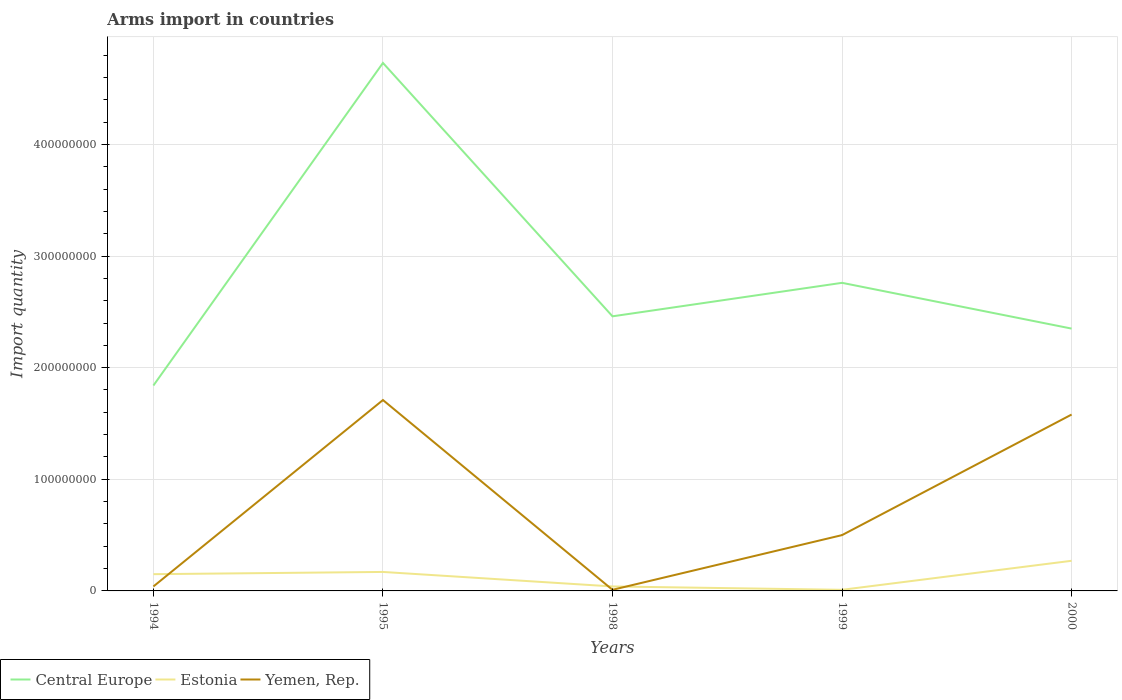In which year was the total arms import in Yemen, Rep. maximum?
Make the answer very short. 1998. What is the total total arms import in Central Europe in the graph?
Offer a very short reply. -9.20e+07. What is the difference between the highest and the second highest total arms import in Estonia?
Provide a succinct answer. 2.60e+07. What is the difference between the highest and the lowest total arms import in Central Europe?
Make the answer very short. 1. How many lines are there?
Give a very brief answer. 3. How many years are there in the graph?
Offer a very short reply. 5. Are the values on the major ticks of Y-axis written in scientific E-notation?
Offer a terse response. No. Does the graph contain grids?
Your response must be concise. Yes. Where does the legend appear in the graph?
Your answer should be compact. Bottom left. How are the legend labels stacked?
Offer a very short reply. Horizontal. What is the title of the graph?
Ensure brevity in your answer.  Arms import in countries. Does "Bhutan" appear as one of the legend labels in the graph?
Ensure brevity in your answer.  No. What is the label or title of the Y-axis?
Offer a terse response. Import quantity. What is the Import quantity of Central Europe in 1994?
Your answer should be compact. 1.84e+08. What is the Import quantity in Estonia in 1994?
Your response must be concise. 1.50e+07. What is the Import quantity of Yemen, Rep. in 1994?
Your answer should be compact. 4.00e+06. What is the Import quantity of Central Europe in 1995?
Make the answer very short. 4.73e+08. What is the Import quantity of Estonia in 1995?
Your answer should be compact. 1.70e+07. What is the Import quantity in Yemen, Rep. in 1995?
Provide a short and direct response. 1.71e+08. What is the Import quantity of Central Europe in 1998?
Give a very brief answer. 2.46e+08. What is the Import quantity in Central Europe in 1999?
Give a very brief answer. 2.76e+08. What is the Import quantity in Estonia in 1999?
Ensure brevity in your answer.  1.00e+06. What is the Import quantity of Yemen, Rep. in 1999?
Offer a terse response. 5.00e+07. What is the Import quantity of Central Europe in 2000?
Offer a terse response. 2.35e+08. What is the Import quantity of Estonia in 2000?
Your answer should be very brief. 2.70e+07. What is the Import quantity of Yemen, Rep. in 2000?
Give a very brief answer. 1.58e+08. Across all years, what is the maximum Import quantity of Central Europe?
Ensure brevity in your answer.  4.73e+08. Across all years, what is the maximum Import quantity of Estonia?
Ensure brevity in your answer.  2.70e+07. Across all years, what is the maximum Import quantity of Yemen, Rep.?
Provide a succinct answer. 1.71e+08. Across all years, what is the minimum Import quantity in Central Europe?
Offer a terse response. 1.84e+08. Across all years, what is the minimum Import quantity in Yemen, Rep.?
Your answer should be very brief. 1.00e+06. What is the total Import quantity in Central Europe in the graph?
Your answer should be very brief. 1.41e+09. What is the total Import quantity of Estonia in the graph?
Give a very brief answer. 6.40e+07. What is the total Import quantity in Yemen, Rep. in the graph?
Offer a terse response. 3.84e+08. What is the difference between the Import quantity of Central Europe in 1994 and that in 1995?
Offer a very short reply. -2.89e+08. What is the difference between the Import quantity in Estonia in 1994 and that in 1995?
Ensure brevity in your answer.  -2.00e+06. What is the difference between the Import quantity in Yemen, Rep. in 1994 and that in 1995?
Provide a short and direct response. -1.67e+08. What is the difference between the Import quantity of Central Europe in 1994 and that in 1998?
Offer a very short reply. -6.20e+07. What is the difference between the Import quantity of Estonia in 1994 and that in 1998?
Ensure brevity in your answer.  1.10e+07. What is the difference between the Import quantity of Yemen, Rep. in 1994 and that in 1998?
Make the answer very short. 3.00e+06. What is the difference between the Import quantity of Central Europe in 1994 and that in 1999?
Provide a short and direct response. -9.20e+07. What is the difference between the Import quantity in Estonia in 1994 and that in 1999?
Provide a short and direct response. 1.40e+07. What is the difference between the Import quantity of Yemen, Rep. in 1994 and that in 1999?
Offer a terse response. -4.60e+07. What is the difference between the Import quantity in Central Europe in 1994 and that in 2000?
Give a very brief answer. -5.10e+07. What is the difference between the Import quantity in Estonia in 1994 and that in 2000?
Provide a short and direct response. -1.20e+07. What is the difference between the Import quantity of Yemen, Rep. in 1994 and that in 2000?
Provide a short and direct response. -1.54e+08. What is the difference between the Import quantity of Central Europe in 1995 and that in 1998?
Make the answer very short. 2.27e+08. What is the difference between the Import quantity in Estonia in 1995 and that in 1998?
Provide a succinct answer. 1.30e+07. What is the difference between the Import quantity in Yemen, Rep. in 1995 and that in 1998?
Offer a terse response. 1.70e+08. What is the difference between the Import quantity in Central Europe in 1995 and that in 1999?
Provide a short and direct response. 1.97e+08. What is the difference between the Import quantity of Estonia in 1995 and that in 1999?
Your response must be concise. 1.60e+07. What is the difference between the Import quantity in Yemen, Rep. in 1995 and that in 1999?
Make the answer very short. 1.21e+08. What is the difference between the Import quantity of Central Europe in 1995 and that in 2000?
Make the answer very short. 2.38e+08. What is the difference between the Import quantity of Estonia in 1995 and that in 2000?
Your response must be concise. -1.00e+07. What is the difference between the Import quantity in Yemen, Rep. in 1995 and that in 2000?
Give a very brief answer. 1.30e+07. What is the difference between the Import quantity in Central Europe in 1998 and that in 1999?
Your answer should be compact. -3.00e+07. What is the difference between the Import quantity in Estonia in 1998 and that in 1999?
Give a very brief answer. 3.00e+06. What is the difference between the Import quantity of Yemen, Rep. in 1998 and that in 1999?
Offer a very short reply. -4.90e+07. What is the difference between the Import quantity of Central Europe in 1998 and that in 2000?
Make the answer very short. 1.10e+07. What is the difference between the Import quantity of Estonia in 1998 and that in 2000?
Provide a short and direct response. -2.30e+07. What is the difference between the Import quantity in Yemen, Rep. in 1998 and that in 2000?
Make the answer very short. -1.57e+08. What is the difference between the Import quantity in Central Europe in 1999 and that in 2000?
Your answer should be very brief. 4.10e+07. What is the difference between the Import quantity in Estonia in 1999 and that in 2000?
Your answer should be very brief. -2.60e+07. What is the difference between the Import quantity of Yemen, Rep. in 1999 and that in 2000?
Make the answer very short. -1.08e+08. What is the difference between the Import quantity of Central Europe in 1994 and the Import quantity of Estonia in 1995?
Provide a short and direct response. 1.67e+08. What is the difference between the Import quantity of Central Europe in 1994 and the Import quantity of Yemen, Rep. in 1995?
Your answer should be compact. 1.30e+07. What is the difference between the Import quantity of Estonia in 1994 and the Import quantity of Yemen, Rep. in 1995?
Your response must be concise. -1.56e+08. What is the difference between the Import quantity of Central Europe in 1994 and the Import quantity of Estonia in 1998?
Provide a succinct answer. 1.80e+08. What is the difference between the Import quantity in Central Europe in 1994 and the Import quantity in Yemen, Rep. in 1998?
Offer a terse response. 1.83e+08. What is the difference between the Import quantity of Estonia in 1994 and the Import quantity of Yemen, Rep. in 1998?
Offer a terse response. 1.40e+07. What is the difference between the Import quantity in Central Europe in 1994 and the Import quantity in Estonia in 1999?
Your response must be concise. 1.83e+08. What is the difference between the Import quantity of Central Europe in 1994 and the Import quantity of Yemen, Rep. in 1999?
Your answer should be compact. 1.34e+08. What is the difference between the Import quantity in Estonia in 1994 and the Import quantity in Yemen, Rep. in 1999?
Your answer should be compact. -3.50e+07. What is the difference between the Import quantity in Central Europe in 1994 and the Import quantity in Estonia in 2000?
Provide a short and direct response. 1.57e+08. What is the difference between the Import quantity in Central Europe in 1994 and the Import quantity in Yemen, Rep. in 2000?
Offer a terse response. 2.60e+07. What is the difference between the Import quantity of Estonia in 1994 and the Import quantity of Yemen, Rep. in 2000?
Provide a short and direct response. -1.43e+08. What is the difference between the Import quantity of Central Europe in 1995 and the Import quantity of Estonia in 1998?
Offer a very short reply. 4.69e+08. What is the difference between the Import quantity in Central Europe in 1995 and the Import quantity in Yemen, Rep. in 1998?
Your response must be concise. 4.72e+08. What is the difference between the Import quantity in Estonia in 1995 and the Import quantity in Yemen, Rep. in 1998?
Give a very brief answer. 1.60e+07. What is the difference between the Import quantity in Central Europe in 1995 and the Import quantity in Estonia in 1999?
Offer a terse response. 4.72e+08. What is the difference between the Import quantity in Central Europe in 1995 and the Import quantity in Yemen, Rep. in 1999?
Your response must be concise. 4.23e+08. What is the difference between the Import quantity in Estonia in 1995 and the Import quantity in Yemen, Rep. in 1999?
Ensure brevity in your answer.  -3.30e+07. What is the difference between the Import quantity in Central Europe in 1995 and the Import quantity in Estonia in 2000?
Offer a terse response. 4.46e+08. What is the difference between the Import quantity in Central Europe in 1995 and the Import quantity in Yemen, Rep. in 2000?
Your response must be concise. 3.15e+08. What is the difference between the Import quantity of Estonia in 1995 and the Import quantity of Yemen, Rep. in 2000?
Your answer should be compact. -1.41e+08. What is the difference between the Import quantity in Central Europe in 1998 and the Import quantity in Estonia in 1999?
Offer a very short reply. 2.45e+08. What is the difference between the Import quantity in Central Europe in 1998 and the Import quantity in Yemen, Rep. in 1999?
Your answer should be very brief. 1.96e+08. What is the difference between the Import quantity of Estonia in 1998 and the Import quantity of Yemen, Rep. in 1999?
Your answer should be compact. -4.60e+07. What is the difference between the Import quantity of Central Europe in 1998 and the Import quantity of Estonia in 2000?
Ensure brevity in your answer.  2.19e+08. What is the difference between the Import quantity of Central Europe in 1998 and the Import quantity of Yemen, Rep. in 2000?
Provide a short and direct response. 8.80e+07. What is the difference between the Import quantity in Estonia in 1998 and the Import quantity in Yemen, Rep. in 2000?
Your answer should be very brief. -1.54e+08. What is the difference between the Import quantity of Central Europe in 1999 and the Import quantity of Estonia in 2000?
Your response must be concise. 2.49e+08. What is the difference between the Import quantity in Central Europe in 1999 and the Import quantity in Yemen, Rep. in 2000?
Your answer should be very brief. 1.18e+08. What is the difference between the Import quantity of Estonia in 1999 and the Import quantity of Yemen, Rep. in 2000?
Make the answer very short. -1.57e+08. What is the average Import quantity in Central Europe per year?
Your response must be concise. 2.83e+08. What is the average Import quantity in Estonia per year?
Make the answer very short. 1.28e+07. What is the average Import quantity in Yemen, Rep. per year?
Provide a short and direct response. 7.68e+07. In the year 1994, what is the difference between the Import quantity of Central Europe and Import quantity of Estonia?
Provide a succinct answer. 1.69e+08. In the year 1994, what is the difference between the Import quantity of Central Europe and Import quantity of Yemen, Rep.?
Keep it short and to the point. 1.80e+08. In the year 1994, what is the difference between the Import quantity of Estonia and Import quantity of Yemen, Rep.?
Provide a succinct answer. 1.10e+07. In the year 1995, what is the difference between the Import quantity in Central Europe and Import quantity in Estonia?
Your answer should be compact. 4.56e+08. In the year 1995, what is the difference between the Import quantity of Central Europe and Import quantity of Yemen, Rep.?
Keep it short and to the point. 3.02e+08. In the year 1995, what is the difference between the Import quantity in Estonia and Import quantity in Yemen, Rep.?
Ensure brevity in your answer.  -1.54e+08. In the year 1998, what is the difference between the Import quantity in Central Europe and Import quantity in Estonia?
Offer a terse response. 2.42e+08. In the year 1998, what is the difference between the Import quantity in Central Europe and Import quantity in Yemen, Rep.?
Ensure brevity in your answer.  2.45e+08. In the year 1998, what is the difference between the Import quantity in Estonia and Import quantity in Yemen, Rep.?
Provide a short and direct response. 3.00e+06. In the year 1999, what is the difference between the Import quantity of Central Europe and Import quantity of Estonia?
Give a very brief answer. 2.75e+08. In the year 1999, what is the difference between the Import quantity of Central Europe and Import quantity of Yemen, Rep.?
Give a very brief answer. 2.26e+08. In the year 1999, what is the difference between the Import quantity of Estonia and Import quantity of Yemen, Rep.?
Your response must be concise. -4.90e+07. In the year 2000, what is the difference between the Import quantity of Central Europe and Import quantity of Estonia?
Ensure brevity in your answer.  2.08e+08. In the year 2000, what is the difference between the Import quantity of Central Europe and Import quantity of Yemen, Rep.?
Your answer should be compact. 7.70e+07. In the year 2000, what is the difference between the Import quantity of Estonia and Import quantity of Yemen, Rep.?
Make the answer very short. -1.31e+08. What is the ratio of the Import quantity of Central Europe in 1994 to that in 1995?
Your answer should be very brief. 0.39. What is the ratio of the Import quantity in Estonia in 1994 to that in 1995?
Give a very brief answer. 0.88. What is the ratio of the Import quantity of Yemen, Rep. in 1994 to that in 1995?
Provide a short and direct response. 0.02. What is the ratio of the Import quantity of Central Europe in 1994 to that in 1998?
Offer a terse response. 0.75. What is the ratio of the Import quantity in Estonia in 1994 to that in 1998?
Give a very brief answer. 3.75. What is the ratio of the Import quantity of Yemen, Rep. in 1994 to that in 1998?
Your response must be concise. 4. What is the ratio of the Import quantity in Estonia in 1994 to that in 1999?
Provide a short and direct response. 15. What is the ratio of the Import quantity of Yemen, Rep. in 1994 to that in 1999?
Give a very brief answer. 0.08. What is the ratio of the Import quantity of Central Europe in 1994 to that in 2000?
Ensure brevity in your answer.  0.78. What is the ratio of the Import quantity of Estonia in 1994 to that in 2000?
Your answer should be very brief. 0.56. What is the ratio of the Import quantity in Yemen, Rep. in 1994 to that in 2000?
Your response must be concise. 0.03. What is the ratio of the Import quantity in Central Europe in 1995 to that in 1998?
Provide a succinct answer. 1.92. What is the ratio of the Import quantity of Estonia in 1995 to that in 1998?
Give a very brief answer. 4.25. What is the ratio of the Import quantity in Yemen, Rep. in 1995 to that in 1998?
Give a very brief answer. 171. What is the ratio of the Import quantity in Central Europe in 1995 to that in 1999?
Provide a short and direct response. 1.71. What is the ratio of the Import quantity of Yemen, Rep. in 1995 to that in 1999?
Ensure brevity in your answer.  3.42. What is the ratio of the Import quantity of Central Europe in 1995 to that in 2000?
Your answer should be compact. 2.01. What is the ratio of the Import quantity in Estonia in 1995 to that in 2000?
Offer a very short reply. 0.63. What is the ratio of the Import quantity in Yemen, Rep. in 1995 to that in 2000?
Make the answer very short. 1.08. What is the ratio of the Import quantity in Central Europe in 1998 to that in 1999?
Offer a very short reply. 0.89. What is the ratio of the Import quantity of Estonia in 1998 to that in 1999?
Your answer should be compact. 4. What is the ratio of the Import quantity in Central Europe in 1998 to that in 2000?
Provide a short and direct response. 1.05. What is the ratio of the Import quantity in Estonia in 1998 to that in 2000?
Your response must be concise. 0.15. What is the ratio of the Import quantity of Yemen, Rep. in 1998 to that in 2000?
Your response must be concise. 0.01. What is the ratio of the Import quantity in Central Europe in 1999 to that in 2000?
Your answer should be compact. 1.17. What is the ratio of the Import quantity of Estonia in 1999 to that in 2000?
Offer a very short reply. 0.04. What is the ratio of the Import quantity in Yemen, Rep. in 1999 to that in 2000?
Your answer should be compact. 0.32. What is the difference between the highest and the second highest Import quantity in Central Europe?
Provide a short and direct response. 1.97e+08. What is the difference between the highest and the second highest Import quantity in Estonia?
Offer a terse response. 1.00e+07. What is the difference between the highest and the second highest Import quantity in Yemen, Rep.?
Keep it short and to the point. 1.30e+07. What is the difference between the highest and the lowest Import quantity of Central Europe?
Offer a very short reply. 2.89e+08. What is the difference between the highest and the lowest Import quantity of Estonia?
Give a very brief answer. 2.60e+07. What is the difference between the highest and the lowest Import quantity of Yemen, Rep.?
Provide a succinct answer. 1.70e+08. 